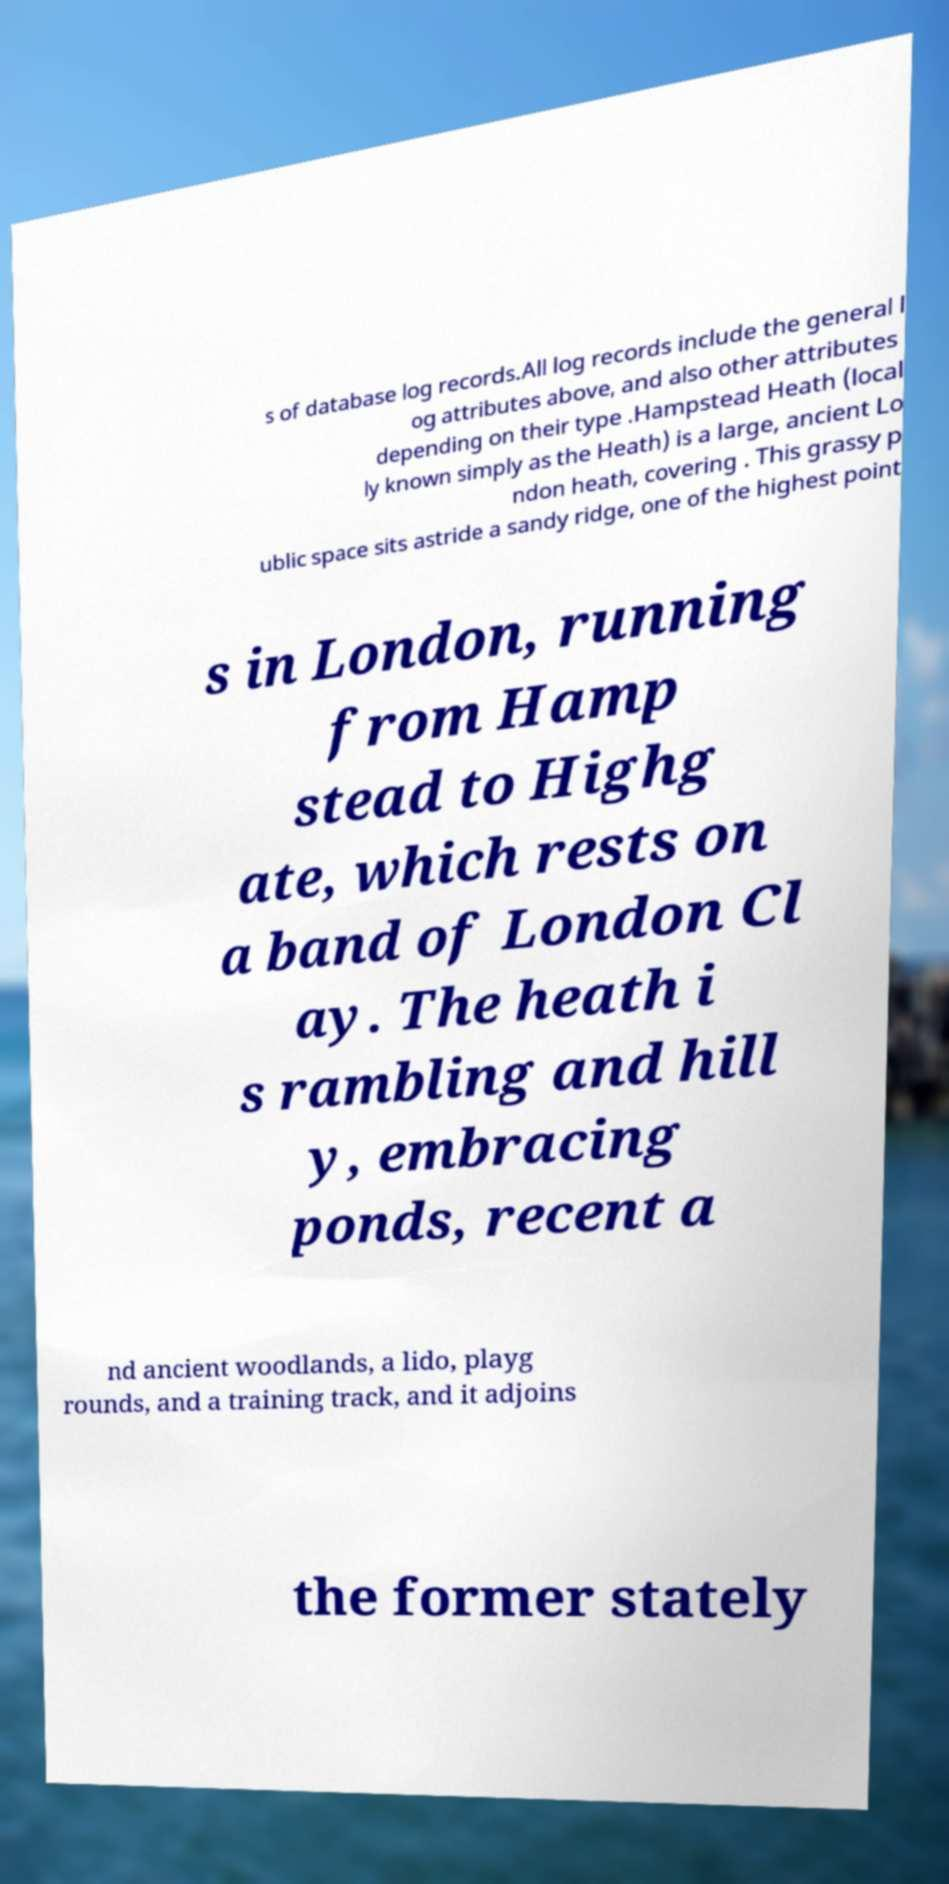Could you extract and type out the text from this image? s of database log records.All log records include the general l og attributes above, and also other attributes depending on their type .Hampstead Heath (local ly known simply as the Heath) is a large, ancient Lo ndon heath, covering . This grassy p ublic space sits astride a sandy ridge, one of the highest point s in London, running from Hamp stead to Highg ate, which rests on a band of London Cl ay. The heath i s rambling and hill y, embracing ponds, recent a nd ancient woodlands, a lido, playg rounds, and a training track, and it adjoins the former stately 